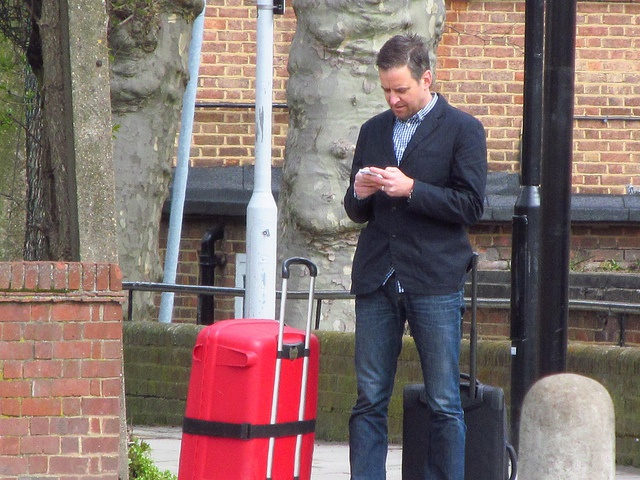Describe the objects in this image and their specific colors. I can see people in black, gray, and darkblue tones, suitcase in black, red, brown, and darkgray tones, suitcase in black and gray tones, and cell phone in black, lavender, pink, darkgray, and lightpink tones in this image. 